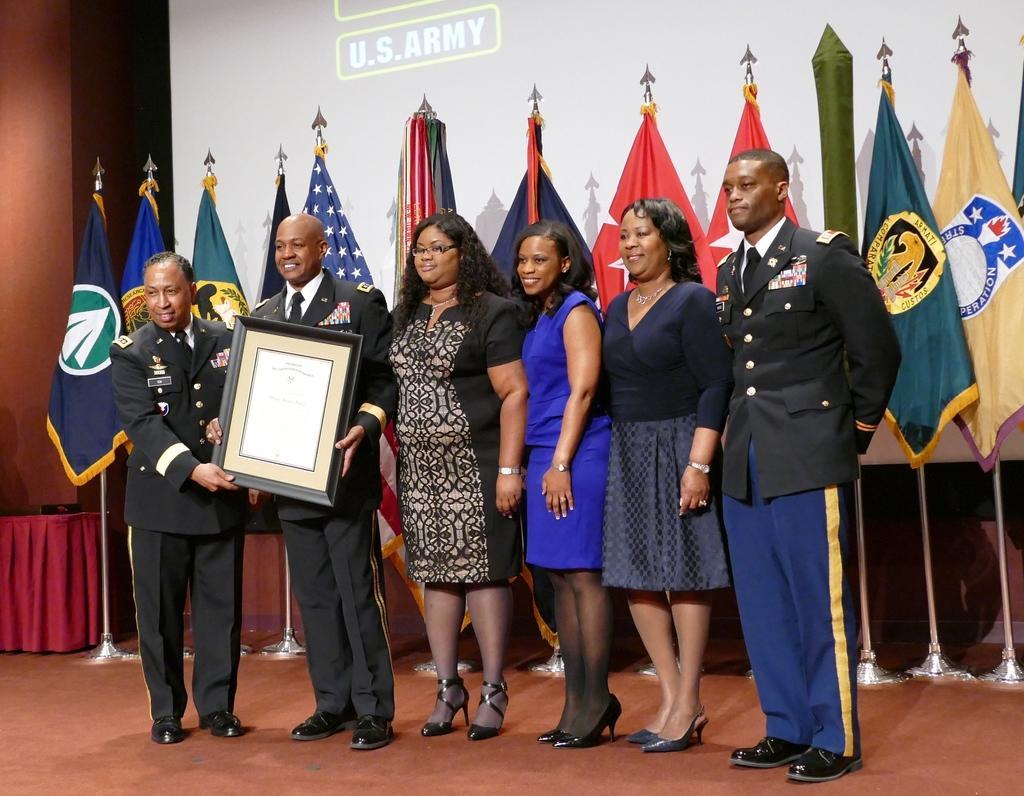Can you describe this image briefly? In this image, we can see a group of people are standing on the floor and smiling. Background there is a screen, flags with pole stand, cloth and wall. 